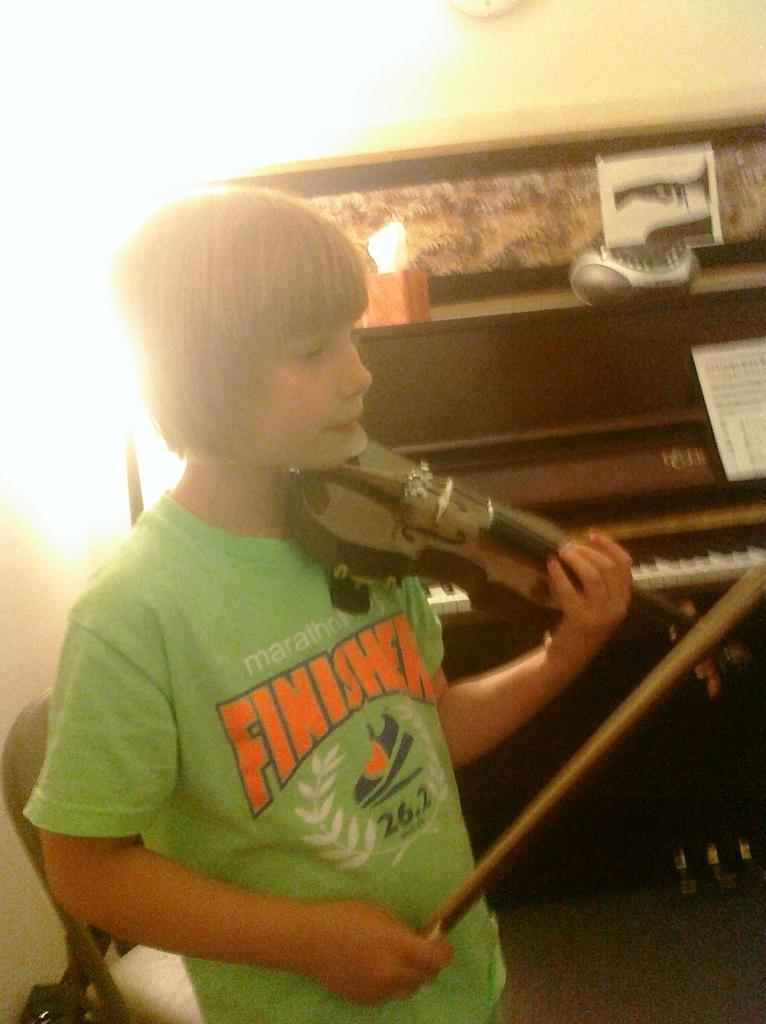In one or two sentences, can you explain what this image depicts? In this image i can see a boy holding a violin in his hand and in the background i can see a piano and a wall. 